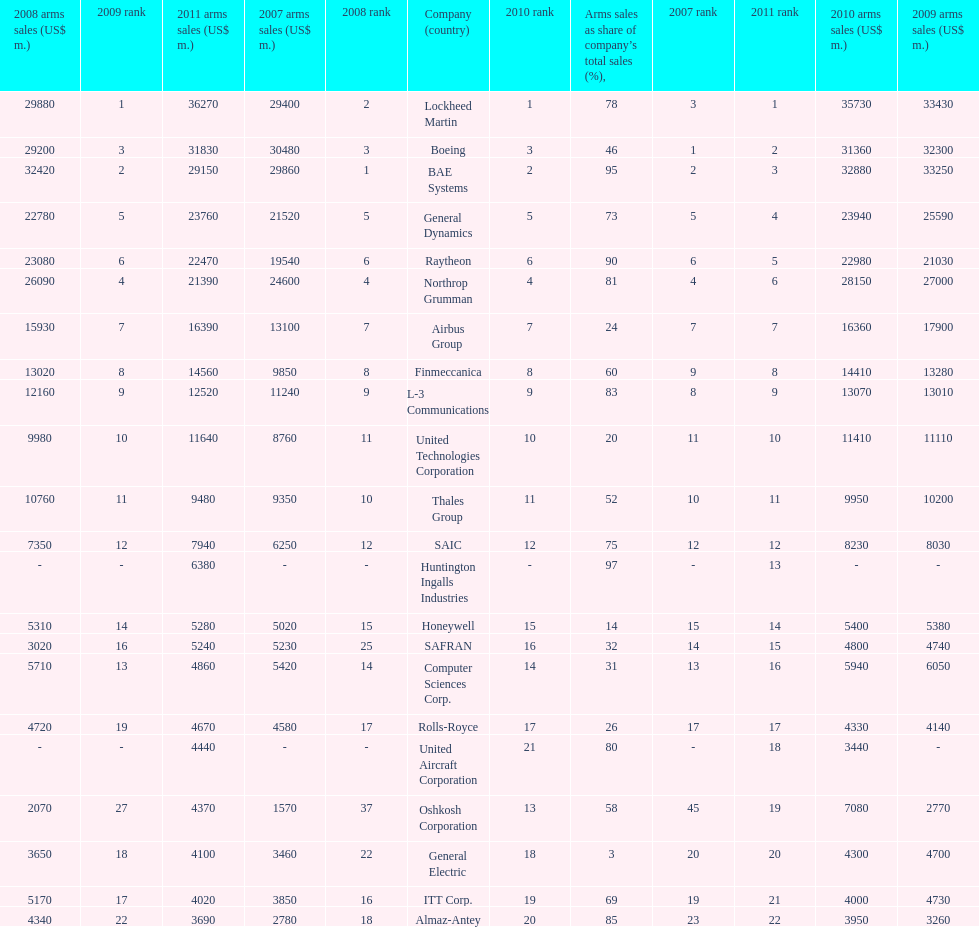How many different countries are listed? 6. 